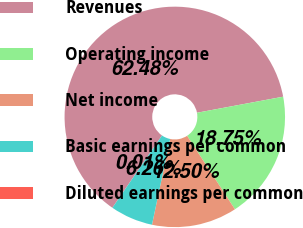<chart> <loc_0><loc_0><loc_500><loc_500><pie_chart><fcel>Revenues<fcel>Operating income<fcel>Net income<fcel>Basic earnings per common<fcel>Diluted earnings per common<nl><fcel>62.47%<fcel>18.75%<fcel>12.5%<fcel>6.26%<fcel>0.01%<nl></chart> 